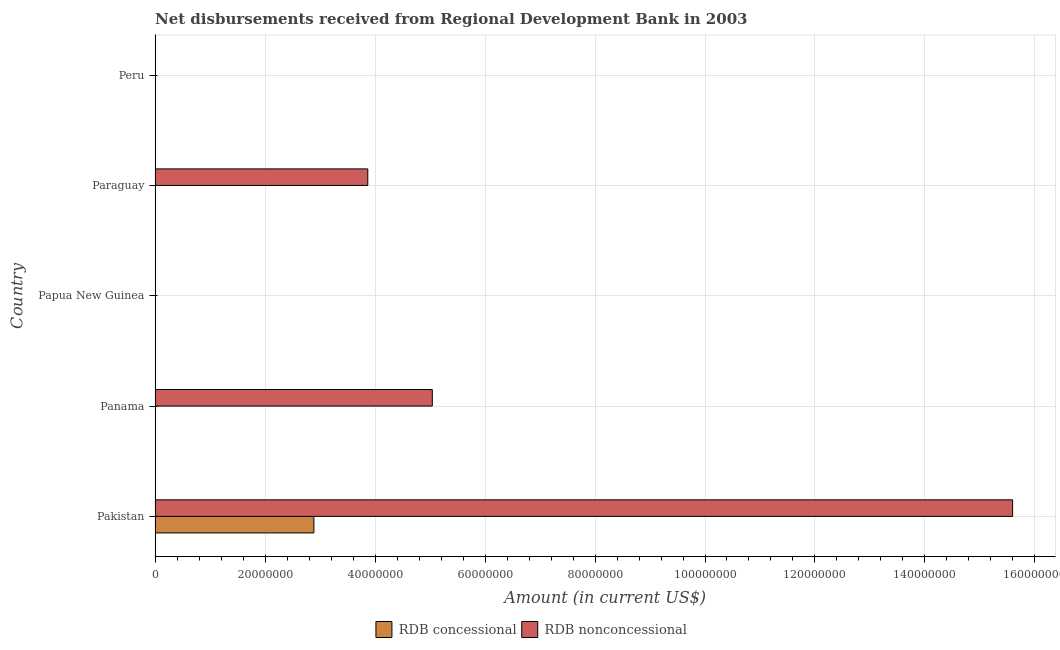Are the number of bars per tick equal to the number of legend labels?
Give a very brief answer. No. How many bars are there on the 4th tick from the top?
Offer a very short reply. 1. What is the label of the 2nd group of bars from the top?
Offer a very short reply. Paraguay. In how many cases, is the number of bars for a given country not equal to the number of legend labels?
Your answer should be very brief. 4. What is the net concessional disbursements from rdb in Papua New Guinea?
Offer a terse response. 0. Across all countries, what is the maximum net concessional disbursements from rdb?
Provide a succinct answer. 2.89e+07. In which country was the net non concessional disbursements from rdb maximum?
Ensure brevity in your answer.  Pakistan. What is the total net concessional disbursements from rdb in the graph?
Offer a terse response. 2.89e+07. What is the difference between the net non concessional disbursements from rdb in Pakistan and that in Panama?
Provide a short and direct response. 1.06e+08. What is the difference between the net concessional disbursements from rdb in Panama and the net non concessional disbursements from rdb in Papua New Guinea?
Offer a very short reply. 0. What is the average net non concessional disbursements from rdb per country?
Offer a terse response. 4.90e+07. What is the difference between the net concessional disbursements from rdb and net non concessional disbursements from rdb in Pakistan?
Your answer should be very brief. -1.27e+08. In how many countries, is the net non concessional disbursements from rdb greater than 8000000 US$?
Your response must be concise. 3. What is the difference between the highest and the second highest net non concessional disbursements from rdb?
Give a very brief answer. 1.06e+08. What is the difference between the highest and the lowest net non concessional disbursements from rdb?
Your response must be concise. 1.56e+08. In how many countries, is the net non concessional disbursements from rdb greater than the average net non concessional disbursements from rdb taken over all countries?
Provide a succinct answer. 2. What is the difference between two consecutive major ticks on the X-axis?
Offer a very short reply. 2.00e+07. Are the values on the major ticks of X-axis written in scientific E-notation?
Provide a short and direct response. No. Does the graph contain grids?
Ensure brevity in your answer.  Yes. How many legend labels are there?
Make the answer very short. 2. What is the title of the graph?
Your answer should be compact. Net disbursements received from Regional Development Bank in 2003. What is the label or title of the Y-axis?
Give a very brief answer. Country. What is the Amount (in current US$) of RDB concessional in Pakistan?
Your answer should be compact. 2.89e+07. What is the Amount (in current US$) of RDB nonconcessional in Pakistan?
Provide a short and direct response. 1.56e+08. What is the Amount (in current US$) of RDB nonconcessional in Panama?
Make the answer very short. 5.04e+07. What is the Amount (in current US$) of RDB concessional in Papua New Guinea?
Offer a very short reply. 0. What is the Amount (in current US$) in RDB concessional in Paraguay?
Make the answer very short. 0. What is the Amount (in current US$) of RDB nonconcessional in Paraguay?
Give a very brief answer. 3.87e+07. What is the Amount (in current US$) of RDB concessional in Peru?
Offer a very short reply. 0. Across all countries, what is the maximum Amount (in current US$) of RDB concessional?
Offer a very short reply. 2.89e+07. Across all countries, what is the maximum Amount (in current US$) in RDB nonconcessional?
Keep it short and to the point. 1.56e+08. Across all countries, what is the minimum Amount (in current US$) of RDB concessional?
Give a very brief answer. 0. Across all countries, what is the minimum Amount (in current US$) of RDB nonconcessional?
Keep it short and to the point. 0. What is the total Amount (in current US$) of RDB concessional in the graph?
Your answer should be compact. 2.89e+07. What is the total Amount (in current US$) of RDB nonconcessional in the graph?
Ensure brevity in your answer.  2.45e+08. What is the difference between the Amount (in current US$) in RDB nonconcessional in Pakistan and that in Panama?
Your answer should be compact. 1.06e+08. What is the difference between the Amount (in current US$) in RDB nonconcessional in Pakistan and that in Paraguay?
Keep it short and to the point. 1.17e+08. What is the difference between the Amount (in current US$) of RDB nonconcessional in Panama and that in Paraguay?
Provide a succinct answer. 1.17e+07. What is the difference between the Amount (in current US$) of RDB concessional in Pakistan and the Amount (in current US$) of RDB nonconcessional in Panama?
Provide a succinct answer. -2.15e+07. What is the difference between the Amount (in current US$) of RDB concessional in Pakistan and the Amount (in current US$) of RDB nonconcessional in Paraguay?
Make the answer very short. -9.80e+06. What is the average Amount (in current US$) in RDB concessional per country?
Your answer should be compact. 5.78e+06. What is the average Amount (in current US$) in RDB nonconcessional per country?
Offer a terse response. 4.90e+07. What is the difference between the Amount (in current US$) in RDB concessional and Amount (in current US$) in RDB nonconcessional in Pakistan?
Your response must be concise. -1.27e+08. What is the ratio of the Amount (in current US$) of RDB nonconcessional in Pakistan to that in Panama?
Offer a very short reply. 3.09. What is the ratio of the Amount (in current US$) of RDB nonconcessional in Pakistan to that in Paraguay?
Make the answer very short. 4.03. What is the ratio of the Amount (in current US$) of RDB nonconcessional in Panama to that in Paraguay?
Ensure brevity in your answer.  1.3. What is the difference between the highest and the second highest Amount (in current US$) in RDB nonconcessional?
Ensure brevity in your answer.  1.06e+08. What is the difference between the highest and the lowest Amount (in current US$) of RDB concessional?
Keep it short and to the point. 2.89e+07. What is the difference between the highest and the lowest Amount (in current US$) of RDB nonconcessional?
Your response must be concise. 1.56e+08. 